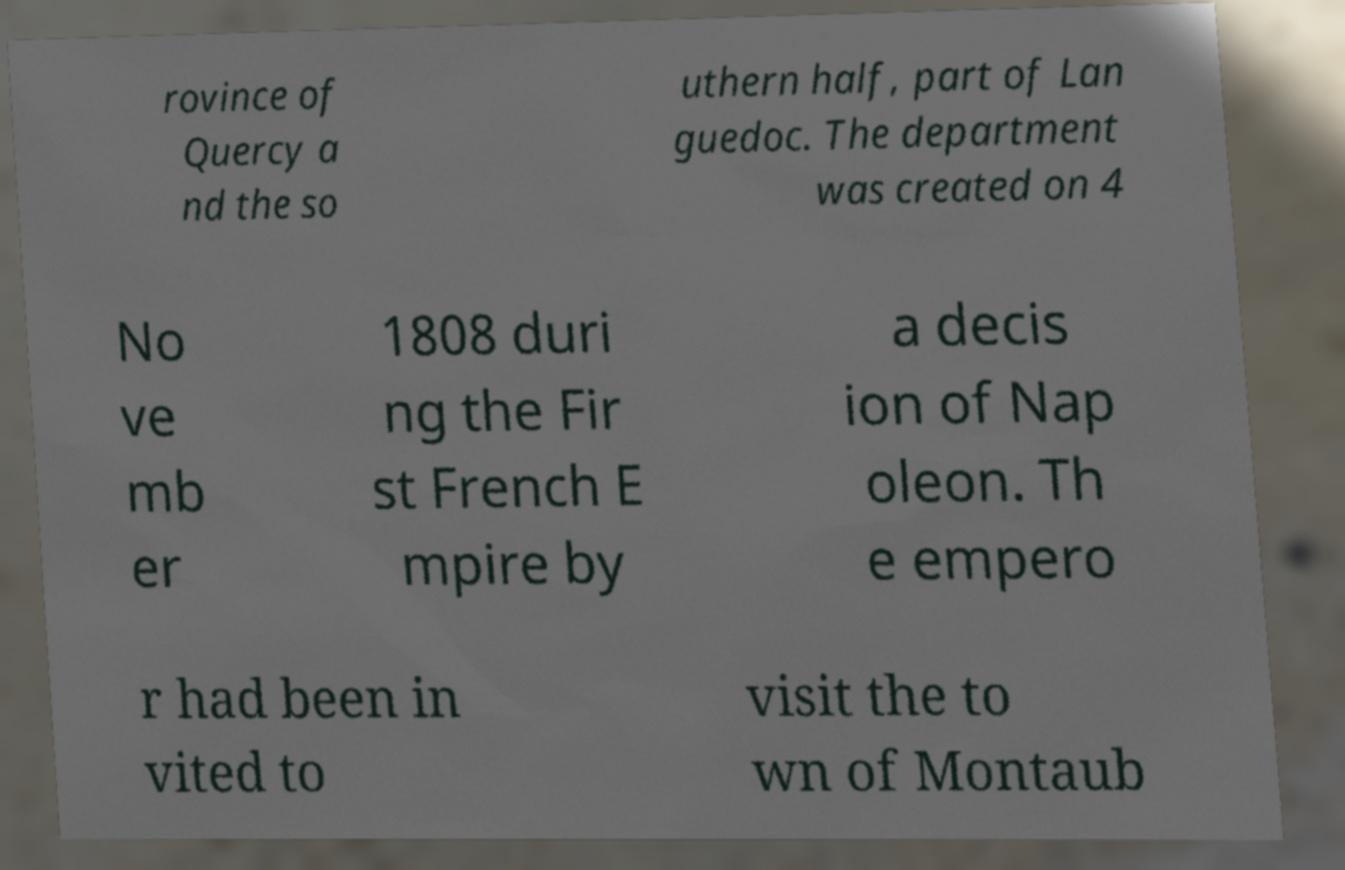I need the written content from this picture converted into text. Can you do that? rovince of Quercy a nd the so uthern half, part of Lan guedoc. The department was created on 4 No ve mb er 1808 duri ng the Fir st French E mpire by a decis ion of Nap oleon. Th e empero r had been in vited to visit the to wn of Montaub 